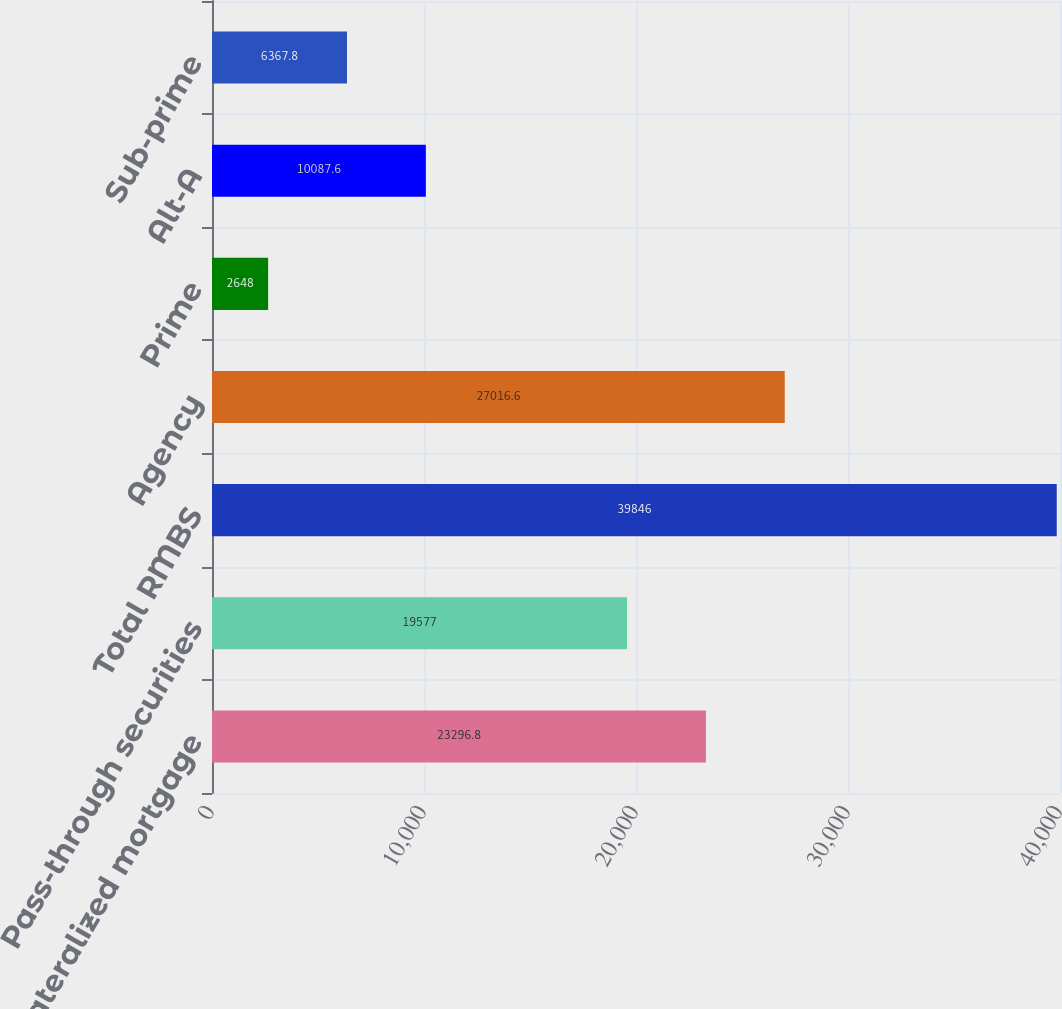Convert chart. <chart><loc_0><loc_0><loc_500><loc_500><bar_chart><fcel>Collateralized mortgage<fcel>Pass-through securities<fcel>Total RMBS<fcel>Agency<fcel>Prime<fcel>Alt-A<fcel>Sub-prime<nl><fcel>23296.8<fcel>19577<fcel>39846<fcel>27016.6<fcel>2648<fcel>10087.6<fcel>6367.8<nl></chart> 